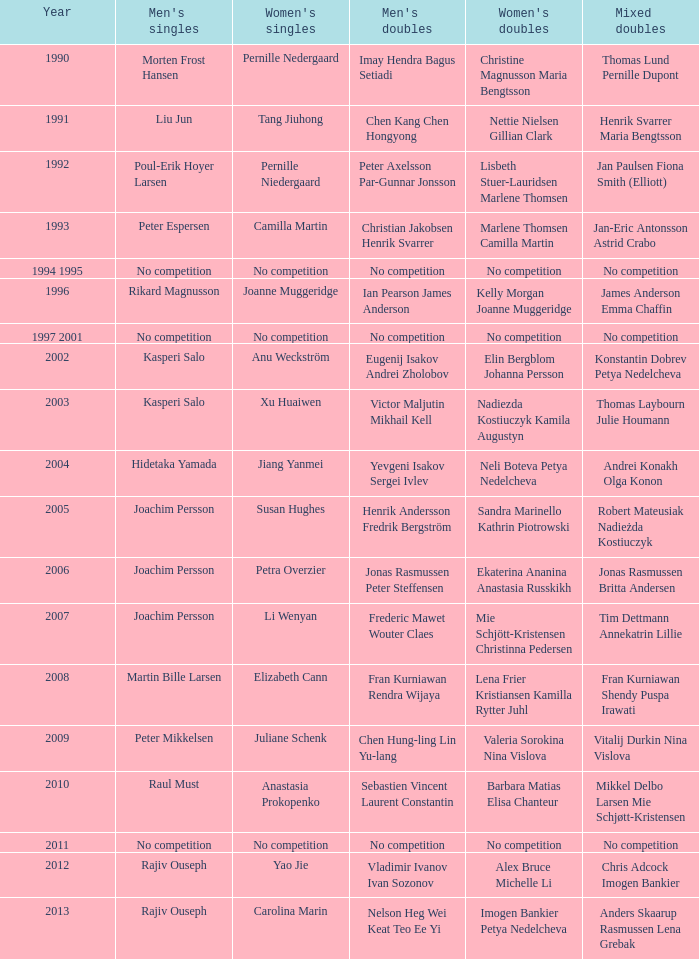What year was carolina marin victorious in the women's singles? 2013.0. 